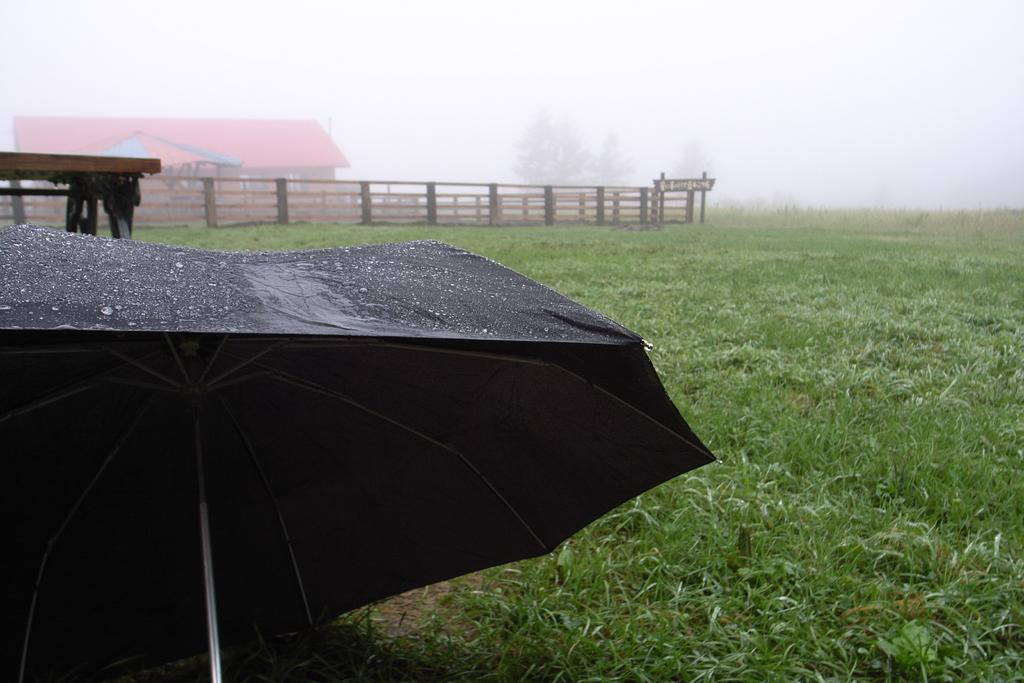What object is located in the front of the image? There is an umbrella in the front of the image. What type of vegetation is at the bottom of the image? Grass is present at the bottom of the image. What can be seen in the background of the image? There is a house and trees visible in the background of the image. What type of barrier is present in the image? There is fencing in the image. What type of peace offering is being made with the umbrella in the image? There is no peace offering being made with the umbrella in the image; it is simply an object located in the front of the image. 